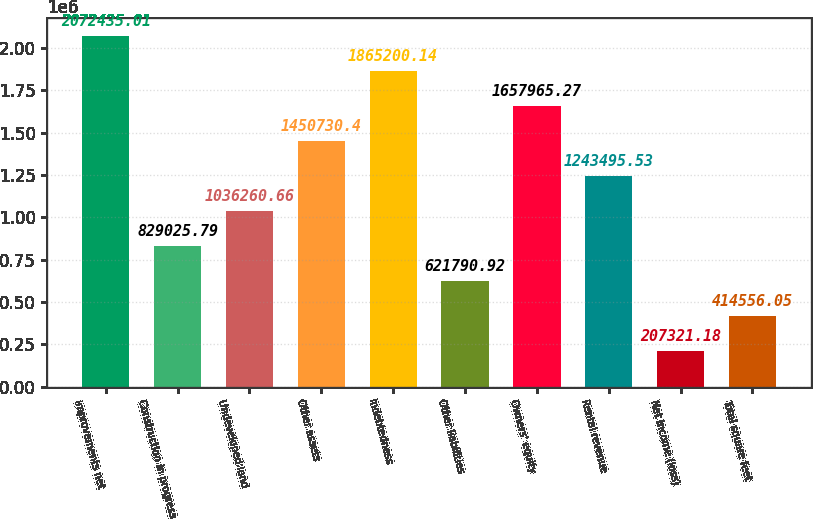<chart> <loc_0><loc_0><loc_500><loc_500><bar_chart><fcel>improvements net<fcel>Construction in progress<fcel>Undeveloped land<fcel>Other assets<fcel>Indebtedness<fcel>Other liabilities<fcel>Owners' equity<fcel>Rental revenue<fcel>Net income (loss)<fcel>Total square feet<nl><fcel>2.07244e+06<fcel>829026<fcel>1.03626e+06<fcel>1.45073e+06<fcel>1.8652e+06<fcel>621791<fcel>1.65797e+06<fcel>1.2435e+06<fcel>207321<fcel>414556<nl></chart> 